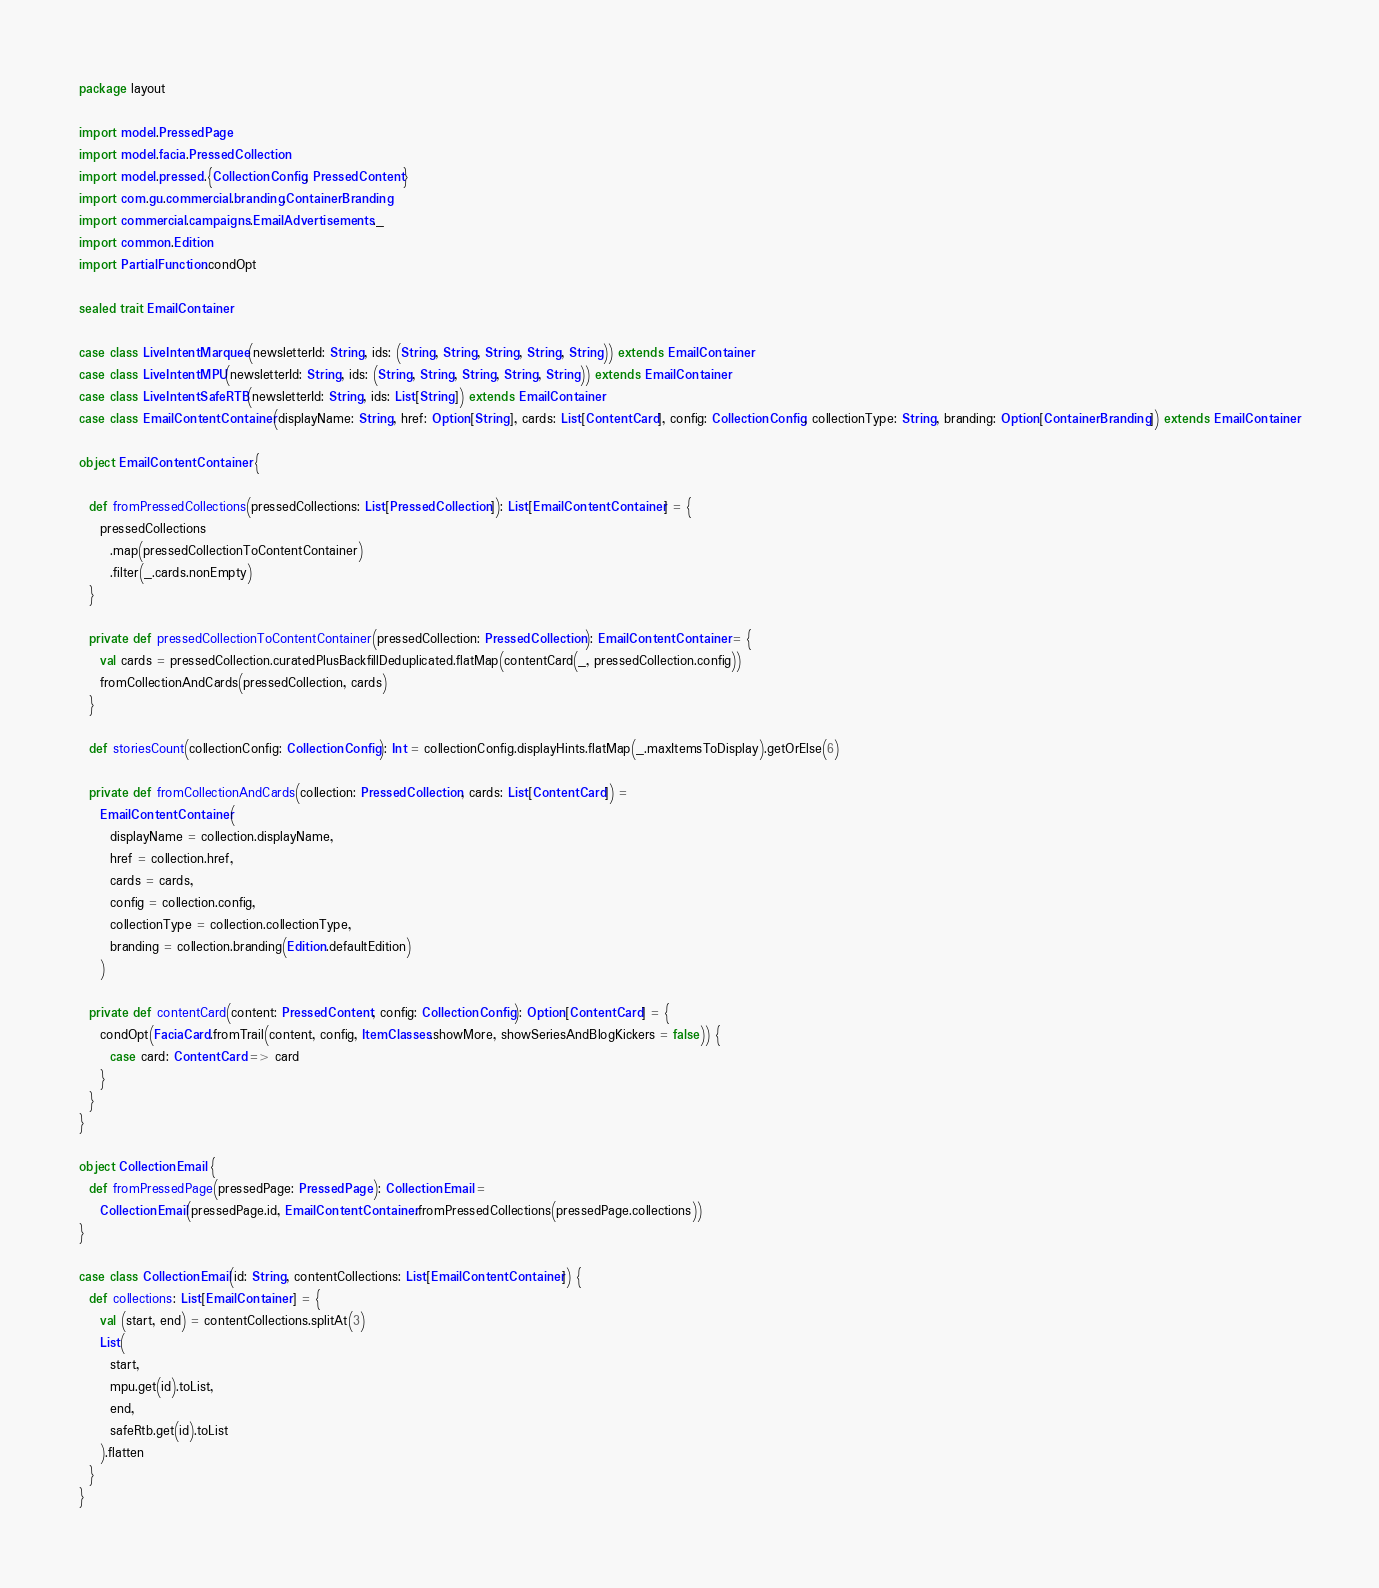<code> <loc_0><loc_0><loc_500><loc_500><_Scala_>package layout

import model.PressedPage
import model.facia.PressedCollection
import model.pressed.{CollectionConfig, PressedContent}
import com.gu.commercial.branding.ContainerBranding
import commercial.campaigns.EmailAdvertisements._
import common.Edition
import PartialFunction.condOpt

sealed trait EmailContainer

case class LiveIntentMarquee(newsletterId: String, ids: (String, String, String, String, String)) extends EmailContainer
case class LiveIntentMPU(newsletterId: String, ids: (String, String, String, String, String)) extends EmailContainer
case class LiveIntentSafeRTB(newsletterId: String, ids: List[String]) extends EmailContainer
case class EmailContentContainer(displayName: String, href: Option[String], cards: List[ContentCard], config: CollectionConfig, collectionType: String, branding: Option[ContainerBranding]) extends EmailContainer

object EmailContentContainer {

  def fromPressedCollections(pressedCollections: List[PressedCollection]): List[EmailContentContainer] = {
    pressedCollections
      .map(pressedCollectionToContentContainer)
      .filter(_.cards.nonEmpty)
  }

  private def pressedCollectionToContentContainer(pressedCollection: PressedCollection): EmailContentContainer = {
    val cards = pressedCollection.curatedPlusBackfillDeduplicated.flatMap(contentCard(_, pressedCollection.config))
    fromCollectionAndCards(pressedCollection, cards)
  }

  def storiesCount(collectionConfig: CollectionConfig): Int = collectionConfig.displayHints.flatMap(_.maxItemsToDisplay).getOrElse(6)

  private def fromCollectionAndCards(collection: PressedCollection, cards: List[ContentCard]) =
    EmailContentContainer(
      displayName = collection.displayName,
      href = collection.href,
      cards = cards,
      config = collection.config,
      collectionType = collection.collectionType,
      branding = collection.branding(Edition.defaultEdition)
    )

  private def contentCard(content: PressedContent, config: CollectionConfig): Option[ContentCard] = {
    condOpt(FaciaCard.fromTrail(content, config, ItemClasses.showMore, showSeriesAndBlogKickers = false)) {
      case card: ContentCard => card
    }
  }
}

object CollectionEmail {
  def fromPressedPage(pressedPage: PressedPage): CollectionEmail =
    CollectionEmail(pressedPage.id, EmailContentContainer.fromPressedCollections(pressedPage.collections))
}

case class CollectionEmail(id: String, contentCollections: List[EmailContentContainer]) {
  def collections: List[EmailContainer] = {
    val (start, end) = contentCollections.splitAt(3)
    List(
      start,
      mpu.get(id).toList,
      end,
      safeRtb.get(id).toList
    ).flatten
  }
}
</code> 